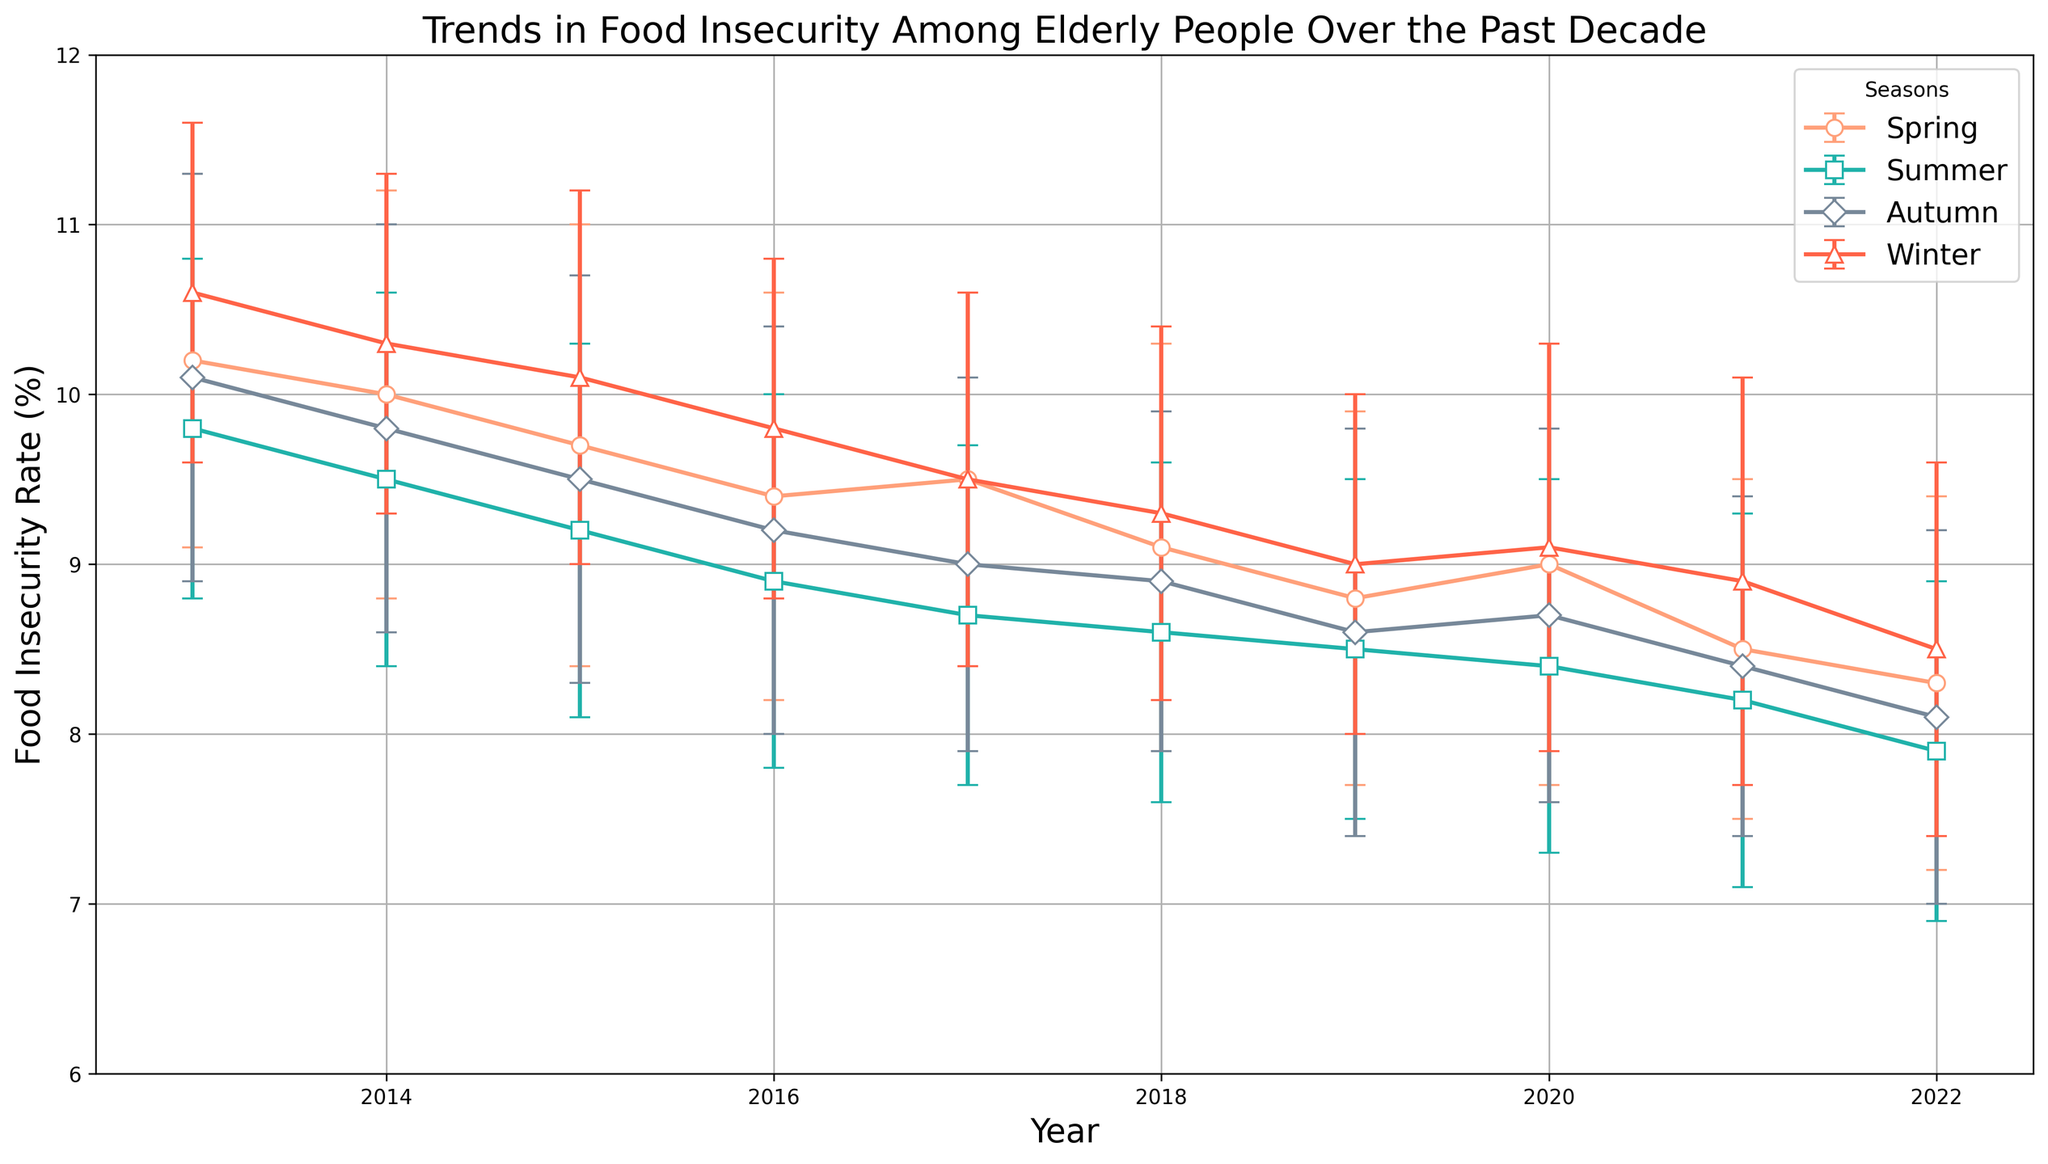What is the general trend of food insecurity rate from 2013 to 2022? Starting from 2013, the food insecurity rate seems to have a general downward trend until 2022. Each year, across all seasons, there seems to be a slight but consistent decrease in the overall food insecurity rate.
Answer: Downward trend In which season does food insecurity seem to peak each year? By examining the plotted points and errors bars, food insecurity appears to be highest during the winter season for most of the years. Specifically, the winter markers are generally located at the higher end across the years.
Answer: Winter How did the food insecurity rate during the summer of 2019 compare to the summer of 2022? To compare the rates, check the plotted points for summer 2019 and summer 2022. In summer 2019, the food insecurity rate is about 8.5%, whereas in summer 2022, it is approximately 7.9%.
Answer: Lower in 2022 Which year had the highest food insecurity rate during the spring? Inspect the 'Spring' rate across all years. In 2013, the spring food insecurity rate is around 10.2%, which is the highest compared to other years.
Answer: 2013 What is the average food insecurity rate for the year 2017 across all seasons? The food insecurity rates for 2017 are: Spring 9.5%, Summer 8.7%, Autumn 9.0%, and Winter 9.5%. The sum of these rates is 36.7%. Dividing by 4 seasons, the average rate is approximately 9.175%.
Answer: 9.175% By how much did the food insecurity rate in autumn change from 2013 to 2022? The autumn rate in 2013 is around 10.1%, and in 2022 it is approximately 8.1%. The change is 10.1% - 8.1% = 2%.
Answer: 2% Which season showed the least decline in food insecurity rate from 2013 to 2022? Observe the trends across the seasons. Winter shows a noticeable decline from 10.6% in 2013 to about 8.5% in 2022, which is less in comparison to the higher decline seen in other seasons.
Answer: Winter In which year did the food insecurity rate during winter first drop below 10%? Examine winter rates year by year: in 2016, winter rate is around 9.8%, which is the first instance below 10%.
Answer: 2016 